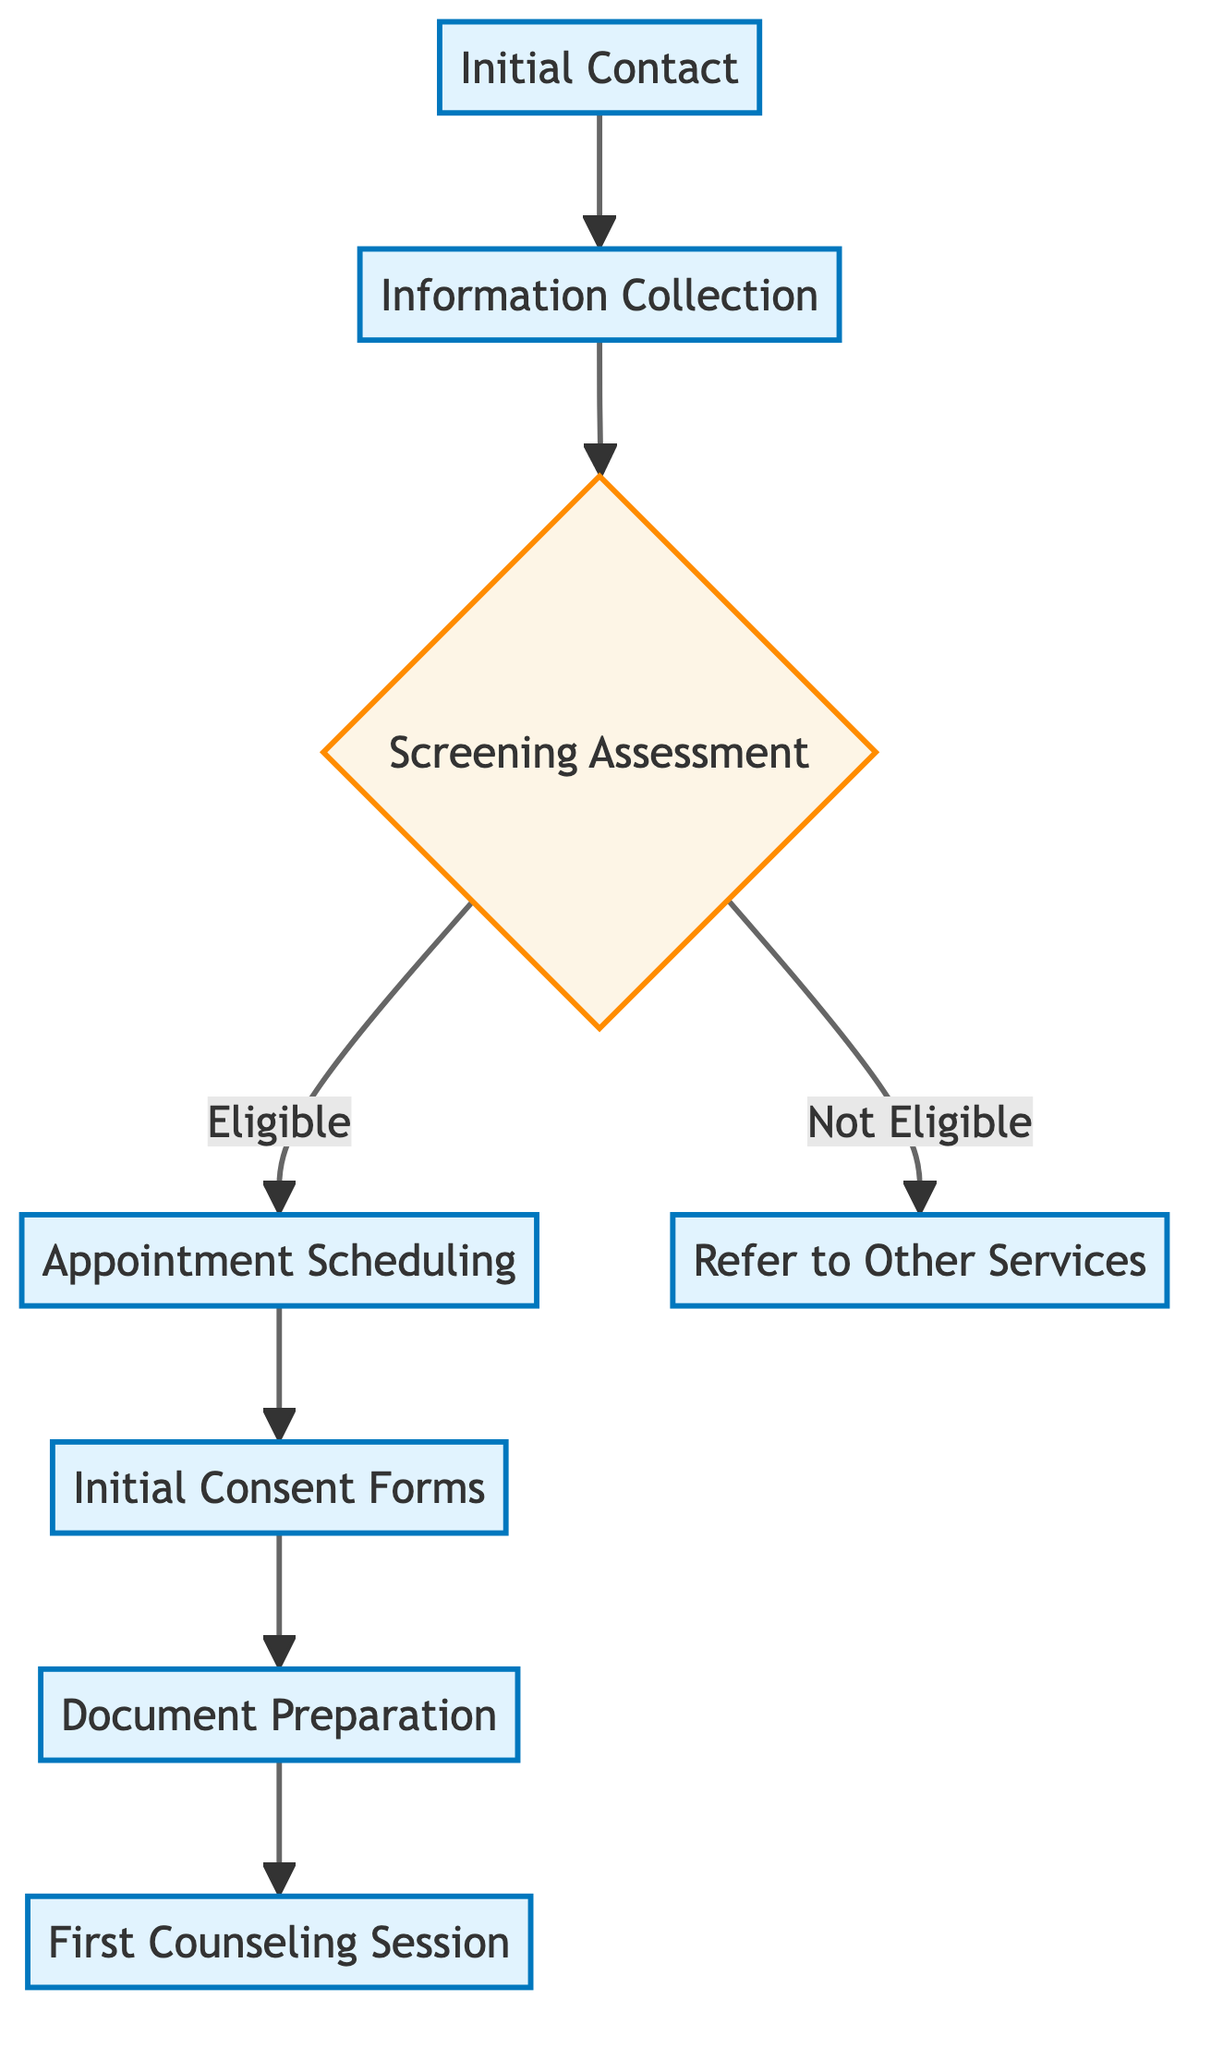What is the first step in the client intake process? The diagram indicates that the first step in the client intake process is "Initial Contact". This is the starting point where potential clients or referral sources make the first phone call or send an email.
Answer: Initial Contact How many main steps are there in this flowchart? By analyzing the flowchart, we can count the main steps from initial contact to the first counseling session. There are a total of 7 main steps visually represented in the diagram.
Answer: 7 What happens if the client is not eligible during the screening assessment? The flowchart outlines a decision point for the screening assessment. If a client is not eligible, the flowchart directs to "Refer to Other Services", indicating the action taken under that condition.
Answer: Refer to Other Services What is scheduled after the screening assessment if the client is eligible? According to the diagram, if the client is eligible after the screening assessment, the next action is "Appointment Scheduling". This is the step that organizes the initial session between the client and counselor.
Answer: Appointment Scheduling Which action comes before the first counseling session? By tracing the flow from the first counseling session back, we find that "Document Preparation" is the step that directly precedes it. This means all necessary documentation is prepared for the session.
Answer: Document Preparation What is needed from the client before the document preparation step? The flowchart states that "Initial Consent Forms" need to be provided and collected from the client before the document preparation can take place. This is crucial for ensuring informed consent from the client.
Answer: Initial Consent Forms What type of assessment is performed after information collection? The diagram specifies that a "Screening Assessment" is carried out following the information collection step. This assessment is crucial to determine the client’s immediate needs and eligibility.
Answer: Screening Assessment Is there a decision point in the client intake process? The flowchart includes a decision point indicated by the screening assessment, where it determines if a client is "Eligible" or "Not Eligible." This decision influences the subsequent steps in the process.
Answer: Yes 